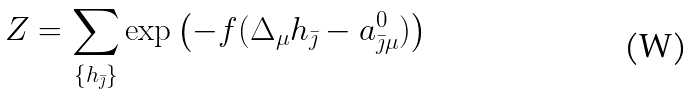Convert formula to latex. <formula><loc_0><loc_0><loc_500><loc_500>Z = \sum _ { \{ h _ { \bar { \jmath } } \} } \exp \left ( - f ( \Delta _ { \mu } h _ { \bar { \jmath } } - a _ { \bar { \jmath } \mu } ^ { 0 } ) \right )</formula> 